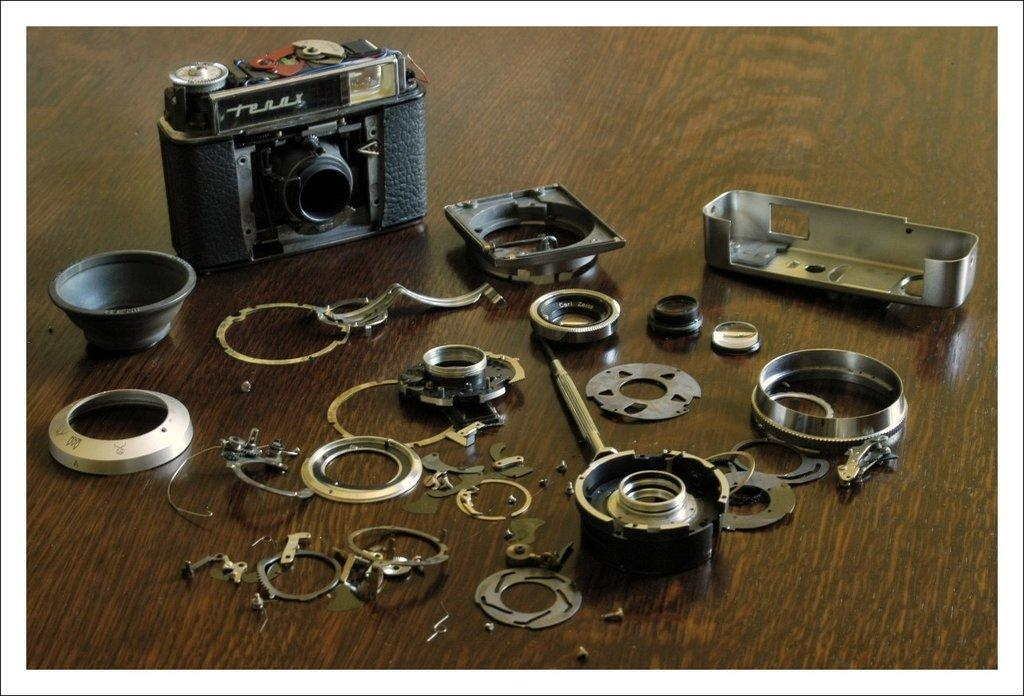What is the main object in the image? There is a camera in the image. What else can be seen on the table in the image? There are other objects on the table in the image. What type of plantation is visible in the image? There is no plantation present in the image; it only features a camera and other objects on a table. 